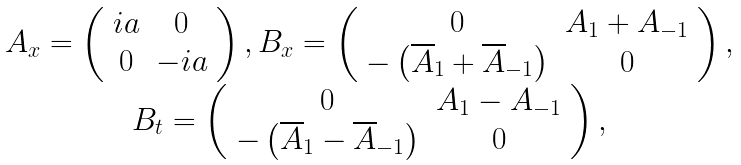<formula> <loc_0><loc_0><loc_500><loc_500>\begin{array} { c } A _ { x } = \left ( \begin{array} { c c } i a & 0 \\ 0 & - i a \end{array} \right ) , B _ { x } = \left ( \begin{array} { c c } 0 & A _ { 1 } + A _ { - 1 } \\ - \left ( \overline { A } _ { 1 } + \overline { A } _ { - 1 } \right ) & 0 \end{array} \right ) , \\ B _ { t } = \left ( \begin{array} { c c } 0 & A _ { 1 } - A _ { - 1 } \\ - \left ( \overline { A } _ { 1 } - \overline { A } _ { - 1 } \right ) & 0 \end{array} \right ) , \end{array}</formula> 